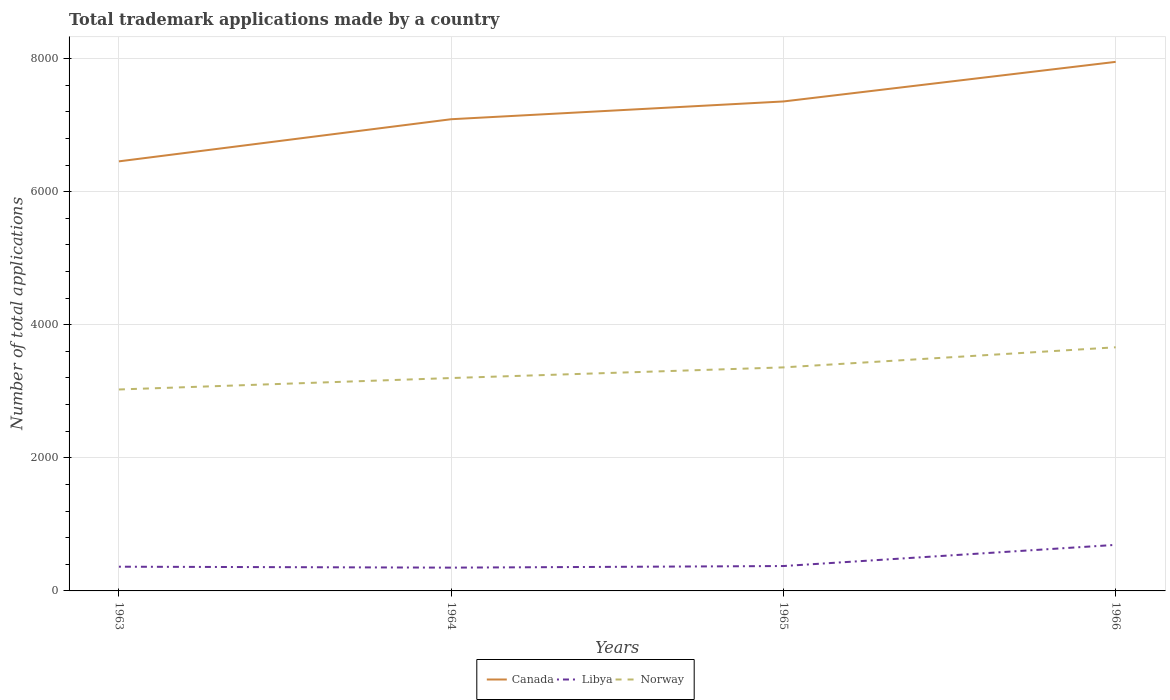Does the line corresponding to Libya intersect with the line corresponding to Canada?
Offer a very short reply. No. Across all years, what is the maximum number of applications made by in Norway?
Keep it short and to the point. 3027. What is the total number of applications made by in Norway in the graph?
Provide a short and direct response. -172. What is the difference between the highest and the second highest number of applications made by in Libya?
Your answer should be compact. 342. What is the difference between the highest and the lowest number of applications made by in Canada?
Provide a succinct answer. 2. How many lines are there?
Your response must be concise. 3. Are the values on the major ticks of Y-axis written in scientific E-notation?
Your response must be concise. No. Does the graph contain grids?
Your answer should be very brief. Yes. Where does the legend appear in the graph?
Keep it short and to the point. Bottom center. How are the legend labels stacked?
Your answer should be very brief. Horizontal. What is the title of the graph?
Provide a succinct answer. Total trademark applications made by a country. Does "Tuvalu" appear as one of the legend labels in the graph?
Provide a succinct answer. No. What is the label or title of the X-axis?
Offer a very short reply. Years. What is the label or title of the Y-axis?
Offer a terse response. Number of total applications. What is the Number of total applications of Canada in 1963?
Offer a very short reply. 6455. What is the Number of total applications in Libya in 1963?
Your response must be concise. 364. What is the Number of total applications in Norway in 1963?
Offer a terse response. 3027. What is the Number of total applications in Canada in 1964?
Your answer should be very brief. 7088. What is the Number of total applications of Libya in 1964?
Provide a short and direct response. 350. What is the Number of total applications in Norway in 1964?
Ensure brevity in your answer.  3199. What is the Number of total applications of Canada in 1965?
Your answer should be compact. 7355. What is the Number of total applications in Libya in 1965?
Provide a succinct answer. 374. What is the Number of total applications of Norway in 1965?
Your response must be concise. 3359. What is the Number of total applications in Canada in 1966?
Your answer should be compact. 7950. What is the Number of total applications in Libya in 1966?
Your response must be concise. 692. What is the Number of total applications in Norway in 1966?
Give a very brief answer. 3661. Across all years, what is the maximum Number of total applications of Canada?
Offer a terse response. 7950. Across all years, what is the maximum Number of total applications in Libya?
Keep it short and to the point. 692. Across all years, what is the maximum Number of total applications of Norway?
Offer a very short reply. 3661. Across all years, what is the minimum Number of total applications in Canada?
Keep it short and to the point. 6455. Across all years, what is the minimum Number of total applications in Libya?
Keep it short and to the point. 350. Across all years, what is the minimum Number of total applications in Norway?
Keep it short and to the point. 3027. What is the total Number of total applications of Canada in the graph?
Give a very brief answer. 2.88e+04. What is the total Number of total applications in Libya in the graph?
Provide a short and direct response. 1780. What is the total Number of total applications in Norway in the graph?
Your answer should be compact. 1.32e+04. What is the difference between the Number of total applications of Canada in 1963 and that in 1964?
Your answer should be compact. -633. What is the difference between the Number of total applications in Libya in 1963 and that in 1964?
Provide a succinct answer. 14. What is the difference between the Number of total applications in Norway in 1963 and that in 1964?
Your answer should be compact. -172. What is the difference between the Number of total applications in Canada in 1963 and that in 1965?
Your answer should be very brief. -900. What is the difference between the Number of total applications in Libya in 1963 and that in 1965?
Your answer should be compact. -10. What is the difference between the Number of total applications of Norway in 1963 and that in 1965?
Provide a short and direct response. -332. What is the difference between the Number of total applications of Canada in 1963 and that in 1966?
Give a very brief answer. -1495. What is the difference between the Number of total applications of Libya in 1963 and that in 1966?
Your answer should be very brief. -328. What is the difference between the Number of total applications in Norway in 1963 and that in 1966?
Give a very brief answer. -634. What is the difference between the Number of total applications in Canada in 1964 and that in 1965?
Your answer should be compact. -267. What is the difference between the Number of total applications of Libya in 1964 and that in 1965?
Offer a very short reply. -24. What is the difference between the Number of total applications in Norway in 1964 and that in 1965?
Provide a short and direct response. -160. What is the difference between the Number of total applications of Canada in 1964 and that in 1966?
Provide a succinct answer. -862. What is the difference between the Number of total applications in Libya in 1964 and that in 1966?
Your answer should be very brief. -342. What is the difference between the Number of total applications in Norway in 1964 and that in 1966?
Ensure brevity in your answer.  -462. What is the difference between the Number of total applications of Canada in 1965 and that in 1966?
Make the answer very short. -595. What is the difference between the Number of total applications in Libya in 1965 and that in 1966?
Your response must be concise. -318. What is the difference between the Number of total applications of Norway in 1965 and that in 1966?
Ensure brevity in your answer.  -302. What is the difference between the Number of total applications of Canada in 1963 and the Number of total applications of Libya in 1964?
Make the answer very short. 6105. What is the difference between the Number of total applications in Canada in 1963 and the Number of total applications in Norway in 1964?
Provide a short and direct response. 3256. What is the difference between the Number of total applications of Libya in 1963 and the Number of total applications of Norway in 1964?
Ensure brevity in your answer.  -2835. What is the difference between the Number of total applications of Canada in 1963 and the Number of total applications of Libya in 1965?
Make the answer very short. 6081. What is the difference between the Number of total applications in Canada in 1963 and the Number of total applications in Norway in 1965?
Your response must be concise. 3096. What is the difference between the Number of total applications of Libya in 1963 and the Number of total applications of Norway in 1965?
Give a very brief answer. -2995. What is the difference between the Number of total applications of Canada in 1963 and the Number of total applications of Libya in 1966?
Make the answer very short. 5763. What is the difference between the Number of total applications in Canada in 1963 and the Number of total applications in Norway in 1966?
Provide a succinct answer. 2794. What is the difference between the Number of total applications of Libya in 1963 and the Number of total applications of Norway in 1966?
Your answer should be very brief. -3297. What is the difference between the Number of total applications in Canada in 1964 and the Number of total applications in Libya in 1965?
Provide a short and direct response. 6714. What is the difference between the Number of total applications of Canada in 1964 and the Number of total applications of Norway in 1965?
Offer a very short reply. 3729. What is the difference between the Number of total applications of Libya in 1964 and the Number of total applications of Norway in 1965?
Provide a succinct answer. -3009. What is the difference between the Number of total applications in Canada in 1964 and the Number of total applications in Libya in 1966?
Offer a very short reply. 6396. What is the difference between the Number of total applications of Canada in 1964 and the Number of total applications of Norway in 1966?
Offer a terse response. 3427. What is the difference between the Number of total applications of Libya in 1964 and the Number of total applications of Norway in 1966?
Provide a short and direct response. -3311. What is the difference between the Number of total applications in Canada in 1965 and the Number of total applications in Libya in 1966?
Provide a succinct answer. 6663. What is the difference between the Number of total applications in Canada in 1965 and the Number of total applications in Norway in 1966?
Give a very brief answer. 3694. What is the difference between the Number of total applications of Libya in 1965 and the Number of total applications of Norway in 1966?
Ensure brevity in your answer.  -3287. What is the average Number of total applications in Canada per year?
Your response must be concise. 7212. What is the average Number of total applications in Libya per year?
Offer a very short reply. 445. What is the average Number of total applications in Norway per year?
Ensure brevity in your answer.  3311.5. In the year 1963, what is the difference between the Number of total applications of Canada and Number of total applications of Libya?
Your answer should be very brief. 6091. In the year 1963, what is the difference between the Number of total applications of Canada and Number of total applications of Norway?
Offer a terse response. 3428. In the year 1963, what is the difference between the Number of total applications in Libya and Number of total applications in Norway?
Provide a short and direct response. -2663. In the year 1964, what is the difference between the Number of total applications of Canada and Number of total applications of Libya?
Provide a succinct answer. 6738. In the year 1964, what is the difference between the Number of total applications in Canada and Number of total applications in Norway?
Offer a very short reply. 3889. In the year 1964, what is the difference between the Number of total applications in Libya and Number of total applications in Norway?
Provide a short and direct response. -2849. In the year 1965, what is the difference between the Number of total applications of Canada and Number of total applications of Libya?
Provide a short and direct response. 6981. In the year 1965, what is the difference between the Number of total applications in Canada and Number of total applications in Norway?
Give a very brief answer. 3996. In the year 1965, what is the difference between the Number of total applications in Libya and Number of total applications in Norway?
Your answer should be compact. -2985. In the year 1966, what is the difference between the Number of total applications in Canada and Number of total applications in Libya?
Keep it short and to the point. 7258. In the year 1966, what is the difference between the Number of total applications in Canada and Number of total applications in Norway?
Offer a terse response. 4289. In the year 1966, what is the difference between the Number of total applications of Libya and Number of total applications of Norway?
Keep it short and to the point. -2969. What is the ratio of the Number of total applications in Canada in 1963 to that in 1964?
Keep it short and to the point. 0.91. What is the ratio of the Number of total applications in Norway in 1963 to that in 1964?
Your response must be concise. 0.95. What is the ratio of the Number of total applications in Canada in 1963 to that in 1965?
Keep it short and to the point. 0.88. What is the ratio of the Number of total applications in Libya in 1963 to that in 1965?
Ensure brevity in your answer.  0.97. What is the ratio of the Number of total applications of Norway in 1963 to that in 1965?
Keep it short and to the point. 0.9. What is the ratio of the Number of total applications in Canada in 1963 to that in 1966?
Make the answer very short. 0.81. What is the ratio of the Number of total applications of Libya in 1963 to that in 1966?
Offer a terse response. 0.53. What is the ratio of the Number of total applications in Norway in 1963 to that in 1966?
Offer a very short reply. 0.83. What is the ratio of the Number of total applications in Canada in 1964 to that in 1965?
Offer a terse response. 0.96. What is the ratio of the Number of total applications in Libya in 1964 to that in 1965?
Your answer should be compact. 0.94. What is the ratio of the Number of total applications in Norway in 1964 to that in 1965?
Offer a very short reply. 0.95. What is the ratio of the Number of total applications in Canada in 1964 to that in 1966?
Your answer should be compact. 0.89. What is the ratio of the Number of total applications of Libya in 1964 to that in 1966?
Provide a succinct answer. 0.51. What is the ratio of the Number of total applications in Norway in 1964 to that in 1966?
Offer a terse response. 0.87. What is the ratio of the Number of total applications in Canada in 1965 to that in 1966?
Your answer should be very brief. 0.93. What is the ratio of the Number of total applications in Libya in 1965 to that in 1966?
Offer a very short reply. 0.54. What is the ratio of the Number of total applications in Norway in 1965 to that in 1966?
Your answer should be very brief. 0.92. What is the difference between the highest and the second highest Number of total applications of Canada?
Your answer should be compact. 595. What is the difference between the highest and the second highest Number of total applications in Libya?
Make the answer very short. 318. What is the difference between the highest and the second highest Number of total applications in Norway?
Your response must be concise. 302. What is the difference between the highest and the lowest Number of total applications in Canada?
Your response must be concise. 1495. What is the difference between the highest and the lowest Number of total applications in Libya?
Your response must be concise. 342. What is the difference between the highest and the lowest Number of total applications of Norway?
Make the answer very short. 634. 